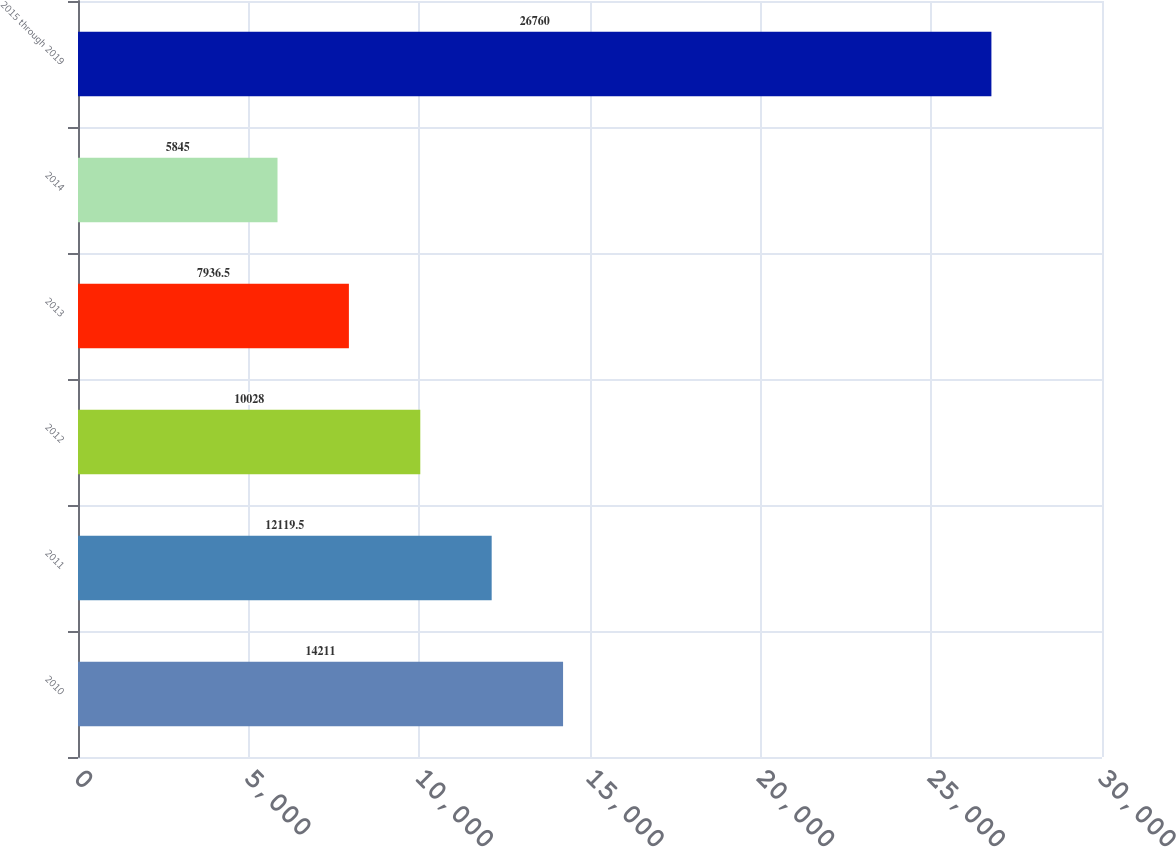Convert chart. <chart><loc_0><loc_0><loc_500><loc_500><bar_chart><fcel>2010<fcel>2011<fcel>2012<fcel>2013<fcel>2014<fcel>2015 through 2019<nl><fcel>14211<fcel>12119.5<fcel>10028<fcel>7936.5<fcel>5845<fcel>26760<nl></chart> 